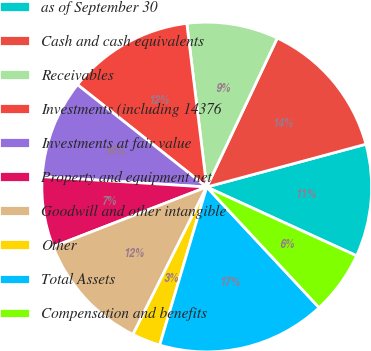Convert chart. <chart><loc_0><loc_0><loc_500><loc_500><pie_chart><fcel>as of September 30<fcel>Cash and cash equivalents<fcel>Receivables<fcel>Investments (including 14376<fcel>Investments at fair value<fcel>Property and equipment net<fcel>Goodwill and other intangible<fcel>Other<fcel>Total Assets<fcel>Compensation and benefits<nl><fcel>11.03%<fcel>13.78%<fcel>8.97%<fcel>12.41%<fcel>9.66%<fcel>6.9%<fcel>11.72%<fcel>2.78%<fcel>16.54%<fcel>6.22%<nl></chart> 